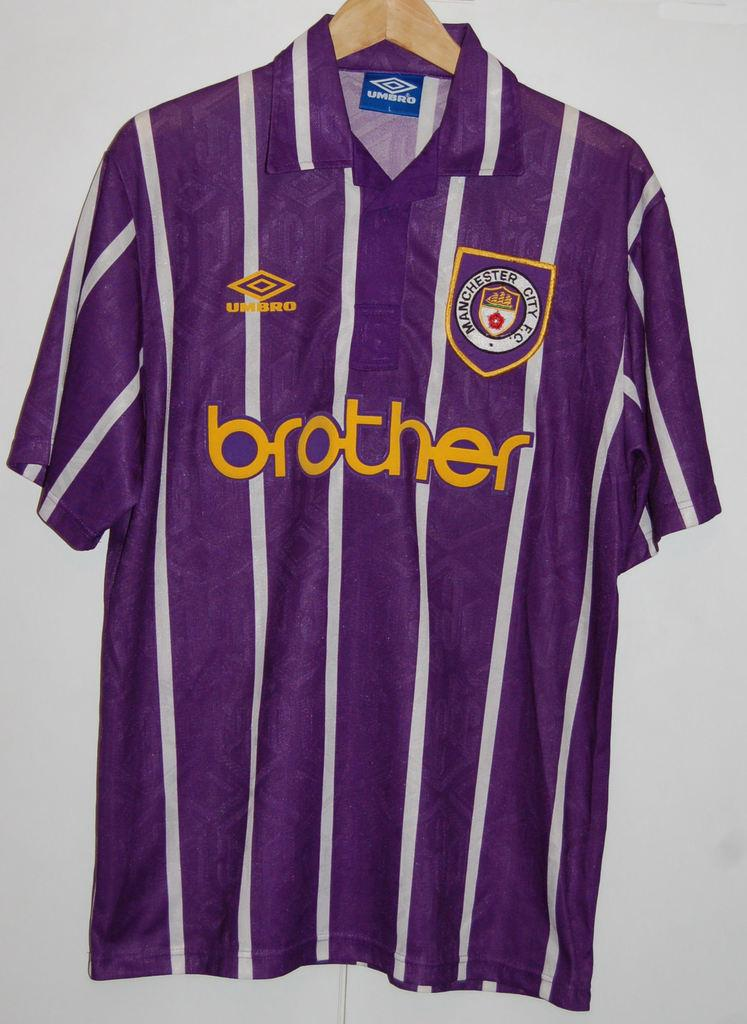Provide a one-sentence caption for the provided image. A purple shirt with white stripes and the word brother across the chest. 